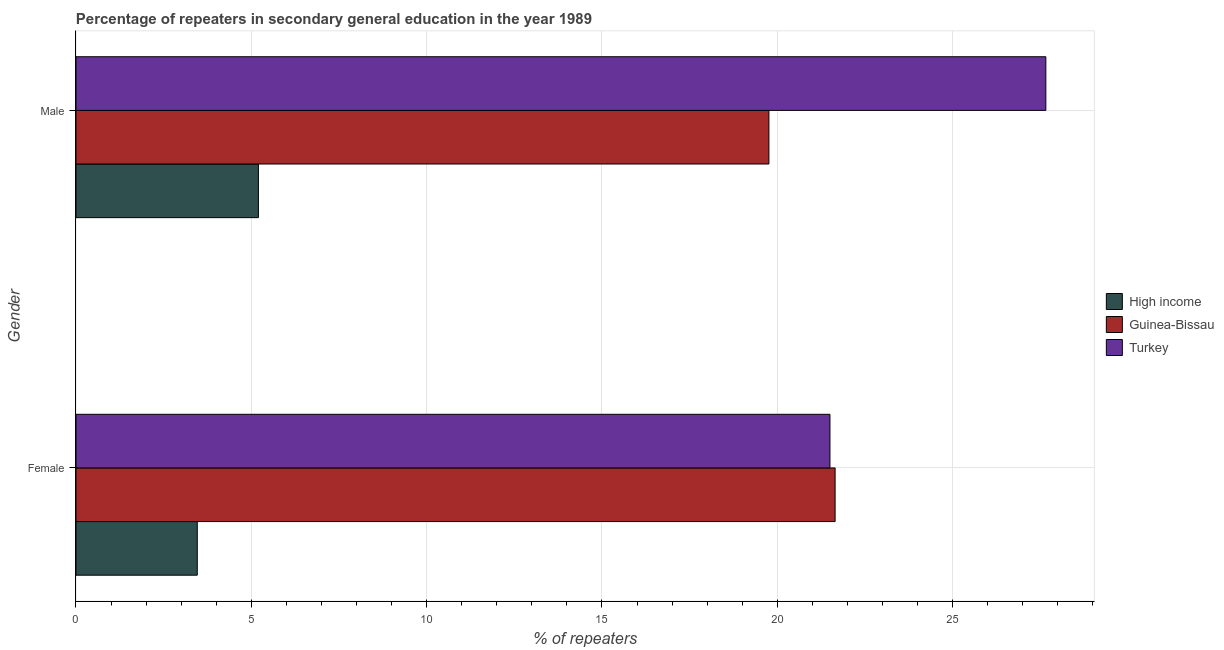How many bars are there on the 2nd tick from the bottom?
Keep it short and to the point. 3. What is the percentage of female repeaters in High income?
Your answer should be compact. 3.46. Across all countries, what is the maximum percentage of male repeaters?
Offer a terse response. 27.66. Across all countries, what is the minimum percentage of male repeaters?
Provide a short and direct response. 5.2. What is the total percentage of male repeaters in the graph?
Provide a succinct answer. 52.62. What is the difference between the percentage of male repeaters in Turkey and that in Guinea-Bissau?
Keep it short and to the point. 7.9. What is the difference between the percentage of male repeaters in Guinea-Bissau and the percentage of female repeaters in Turkey?
Keep it short and to the point. -1.74. What is the average percentage of female repeaters per country?
Ensure brevity in your answer.  15.54. What is the difference between the percentage of female repeaters and percentage of male repeaters in Guinea-Bissau?
Provide a short and direct response. 1.89. What is the ratio of the percentage of male repeaters in High income to that in Turkey?
Ensure brevity in your answer.  0.19. Is the percentage of female repeaters in High income less than that in Turkey?
Your response must be concise. Yes. In how many countries, is the percentage of female repeaters greater than the average percentage of female repeaters taken over all countries?
Offer a terse response. 2. What does the 1st bar from the top in Male represents?
Make the answer very short. Turkey. Are all the bars in the graph horizontal?
Provide a short and direct response. Yes. How many countries are there in the graph?
Your answer should be very brief. 3. What is the difference between two consecutive major ticks on the X-axis?
Provide a short and direct response. 5. How many legend labels are there?
Make the answer very short. 3. What is the title of the graph?
Provide a short and direct response. Percentage of repeaters in secondary general education in the year 1989. Does "OECD members" appear as one of the legend labels in the graph?
Provide a short and direct response. No. What is the label or title of the X-axis?
Give a very brief answer. % of repeaters. What is the label or title of the Y-axis?
Provide a short and direct response. Gender. What is the % of repeaters in High income in Female?
Provide a succinct answer. 3.46. What is the % of repeaters in Guinea-Bissau in Female?
Give a very brief answer. 21.65. What is the % of repeaters in Turkey in Female?
Your response must be concise. 21.5. What is the % of repeaters in High income in Male?
Offer a very short reply. 5.2. What is the % of repeaters of Guinea-Bissau in Male?
Offer a terse response. 19.76. What is the % of repeaters in Turkey in Male?
Offer a terse response. 27.66. Across all Gender, what is the maximum % of repeaters of High income?
Provide a short and direct response. 5.2. Across all Gender, what is the maximum % of repeaters in Guinea-Bissau?
Make the answer very short. 21.65. Across all Gender, what is the maximum % of repeaters of Turkey?
Make the answer very short. 27.66. Across all Gender, what is the minimum % of repeaters of High income?
Give a very brief answer. 3.46. Across all Gender, what is the minimum % of repeaters in Guinea-Bissau?
Your answer should be compact. 19.76. Across all Gender, what is the minimum % of repeaters of Turkey?
Provide a short and direct response. 21.5. What is the total % of repeaters of High income in the graph?
Ensure brevity in your answer.  8.66. What is the total % of repeaters in Guinea-Bissau in the graph?
Offer a terse response. 41.41. What is the total % of repeaters in Turkey in the graph?
Provide a succinct answer. 49.16. What is the difference between the % of repeaters in High income in Female and that in Male?
Keep it short and to the point. -1.74. What is the difference between the % of repeaters of Guinea-Bissau in Female and that in Male?
Your response must be concise. 1.89. What is the difference between the % of repeaters in Turkey in Female and that in Male?
Make the answer very short. -6.16. What is the difference between the % of repeaters in High income in Female and the % of repeaters in Guinea-Bissau in Male?
Give a very brief answer. -16.3. What is the difference between the % of repeaters of High income in Female and the % of repeaters of Turkey in Male?
Keep it short and to the point. -24.2. What is the difference between the % of repeaters in Guinea-Bissau in Female and the % of repeaters in Turkey in Male?
Your response must be concise. -6.01. What is the average % of repeaters in High income per Gender?
Offer a very short reply. 4.33. What is the average % of repeaters in Guinea-Bissau per Gender?
Your response must be concise. 20.7. What is the average % of repeaters of Turkey per Gender?
Ensure brevity in your answer.  24.58. What is the difference between the % of repeaters in High income and % of repeaters in Guinea-Bissau in Female?
Keep it short and to the point. -18.19. What is the difference between the % of repeaters of High income and % of repeaters of Turkey in Female?
Ensure brevity in your answer.  -18.04. What is the difference between the % of repeaters of Guinea-Bissau and % of repeaters of Turkey in Female?
Keep it short and to the point. 0.15. What is the difference between the % of repeaters of High income and % of repeaters of Guinea-Bissau in Male?
Provide a short and direct response. -14.56. What is the difference between the % of repeaters of High income and % of repeaters of Turkey in Male?
Offer a terse response. -22.46. What is the difference between the % of repeaters of Guinea-Bissau and % of repeaters of Turkey in Male?
Provide a succinct answer. -7.9. What is the ratio of the % of repeaters in High income in Female to that in Male?
Ensure brevity in your answer.  0.66. What is the ratio of the % of repeaters of Guinea-Bissau in Female to that in Male?
Offer a terse response. 1.1. What is the ratio of the % of repeaters of Turkey in Female to that in Male?
Your response must be concise. 0.78. What is the difference between the highest and the second highest % of repeaters of High income?
Make the answer very short. 1.74. What is the difference between the highest and the second highest % of repeaters of Guinea-Bissau?
Your answer should be very brief. 1.89. What is the difference between the highest and the second highest % of repeaters of Turkey?
Provide a succinct answer. 6.16. What is the difference between the highest and the lowest % of repeaters of High income?
Your response must be concise. 1.74. What is the difference between the highest and the lowest % of repeaters in Guinea-Bissau?
Ensure brevity in your answer.  1.89. What is the difference between the highest and the lowest % of repeaters in Turkey?
Your answer should be compact. 6.16. 